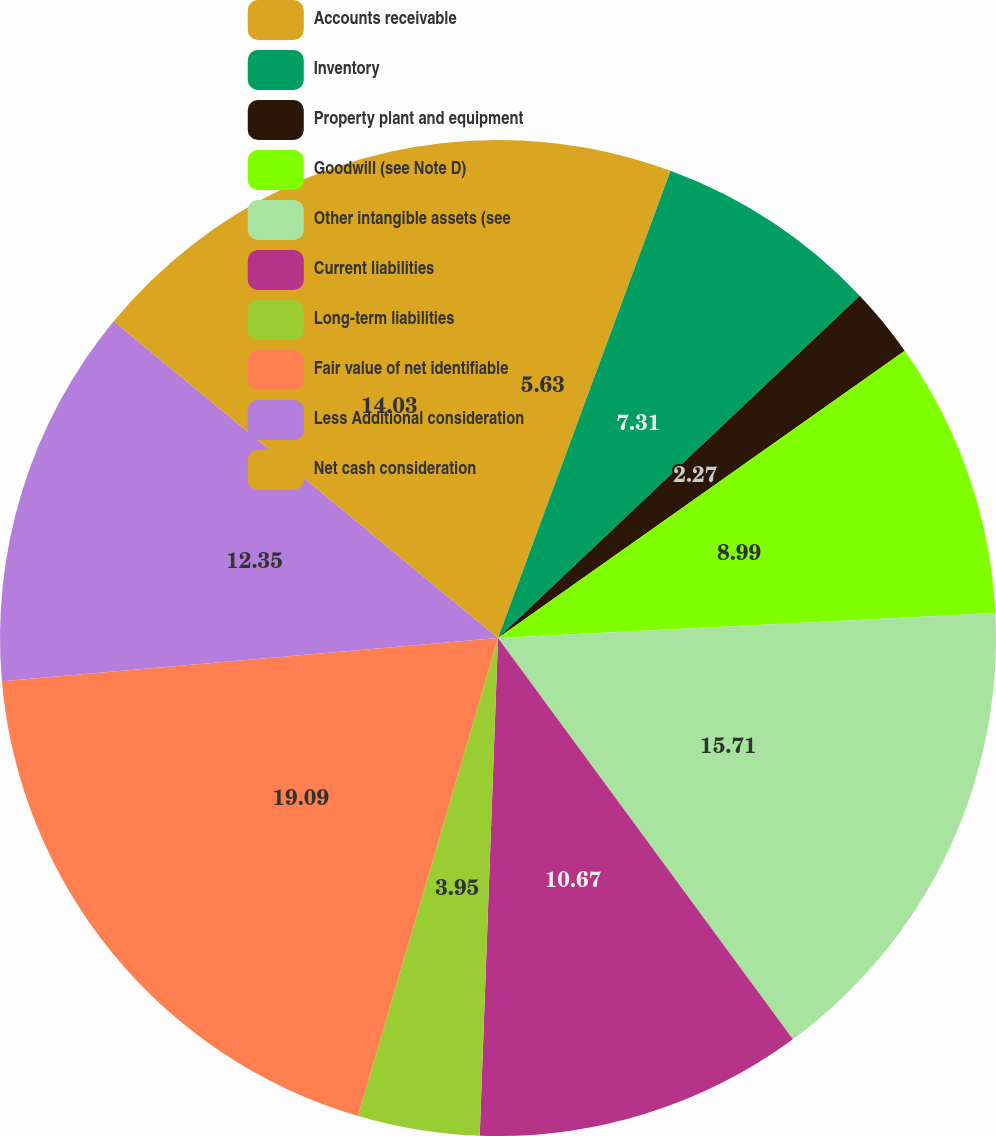Convert chart to OTSL. <chart><loc_0><loc_0><loc_500><loc_500><pie_chart><fcel>Accounts receivable<fcel>Inventory<fcel>Property plant and equipment<fcel>Goodwill (see Note D)<fcel>Other intangible assets (see<fcel>Current liabilities<fcel>Long-term liabilities<fcel>Fair value of net identifiable<fcel>Less Additional consideration<fcel>Net cash consideration<nl><fcel>5.63%<fcel>7.31%<fcel>2.27%<fcel>8.99%<fcel>15.71%<fcel>10.67%<fcel>3.95%<fcel>19.08%<fcel>12.35%<fcel>14.03%<nl></chart> 